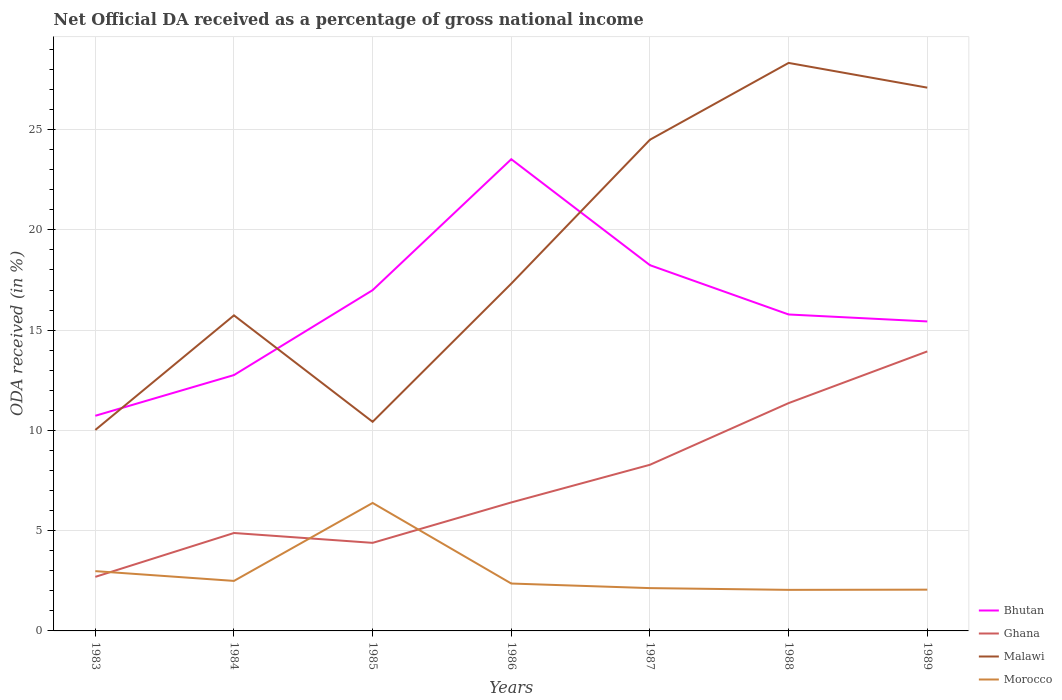Across all years, what is the maximum net official DA received in Ghana?
Give a very brief answer. 2.7. What is the total net official DA received in Malawi in the graph?
Provide a succinct answer. -7.18. What is the difference between the highest and the second highest net official DA received in Malawi?
Ensure brevity in your answer.  18.3. What is the difference between the highest and the lowest net official DA received in Malawi?
Keep it short and to the point. 3. Is the net official DA received in Ghana strictly greater than the net official DA received in Morocco over the years?
Make the answer very short. No. Are the values on the major ticks of Y-axis written in scientific E-notation?
Your response must be concise. No. Does the graph contain any zero values?
Ensure brevity in your answer.  No. What is the title of the graph?
Offer a very short reply. Net Official DA received as a percentage of gross national income. What is the label or title of the X-axis?
Your answer should be compact. Years. What is the label or title of the Y-axis?
Ensure brevity in your answer.  ODA received (in %). What is the ODA received (in %) of Bhutan in 1983?
Keep it short and to the point. 10.73. What is the ODA received (in %) in Ghana in 1983?
Provide a succinct answer. 2.7. What is the ODA received (in %) in Malawi in 1983?
Keep it short and to the point. 10.02. What is the ODA received (in %) of Morocco in 1983?
Ensure brevity in your answer.  2.98. What is the ODA received (in %) in Bhutan in 1984?
Provide a succinct answer. 12.76. What is the ODA received (in %) of Ghana in 1984?
Give a very brief answer. 4.88. What is the ODA received (in %) of Malawi in 1984?
Offer a terse response. 15.74. What is the ODA received (in %) in Morocco in 1984?
Provide a succinct answer. 2.49. What is the ODA received (in %) of Bhutan in 1985?
Offer a terse response. 16.99. What is the ODA received (in %) in Ghana in 1985?
Offer a terse response. 4.39. What is the ODA received (in %) of Malawi in 1985?
Make the answer very short. 10.43. What is the ODA received (in %) in Morocco in 1985?
Provide a short and direct response. 6.38. What is the ODA received (in %) of Bhutan in 1986?
Make the answer very short. 23.52. What is the ODA received (in %) in Ghana in 1986?
Provide a short and direct response. 6.41. What is the ODA received (in %) in Malawi in 1986?
Offer a terse response. 17.32. What is the ODA received (in %) in Morocco in 1986?
Keep it short and to the point. 2.36. What is the ODA received (in %) in Bhutan in 1987?
Your answer should be compact. 18.24. What is the ODA received (in %) of Ghana in 1987?
Your response must be concise. 8.29. What is the ODA received (in %) of Malawi in 1987?
Your response must be concise. 24.49. What is the ODA received (in %) of Morocco in 1987?
Offer a very short reply. 2.13. What is the ODA received (in %) of Bhutan in 1988?
Make the answer very short. 15.78. What is the ODA received (in %) of Ghana in 1988?
Offer a terse response. 11.36. What is the ODA received (in %) in Malawi in 1988?
Ensure brevity in your answer.  28.32. What is the ODA received (in %) of Morocco in 1988?
Offer a terse response. 2.05. What is the ODA received (in %) of Bhutan in 1989?
Your response must be concise. 15.43. What is the ODA received (in %) in Ghana in 1989?
Give a very brief answer. 13.94. What is the ODA received (in %) in Malawi in 1989?
Give a very brief answer. 27.09. What is the ODA received (in %) of Morocco in 1989?
Give a very brief answer. 2.06. Across all years, what is the maximum ODA received (in %) in Bhutan?
Offer a terse response. 23.52. Across all years, what is the maximum ODA received (in %) in Ghana?
Make the answer very short. 13.94. Across all years, what is the maximum ODA received (in %) in Malawi?
Provide a short and direct response. 28.32. Across all years, what is the maximum ODA received (in %) of Morocco?
Your response must be concise. 6.38. Across all years, what is the minimum ODA received (in %) of Bhutan?
Your response must be concise. 10.73. Across all years, what is the minimum ODA received (in %) of Ghana?
Ensure brevity in your answer.  2.7. Across all years, what is the minimum ODA received (in %) of Malawi?
Make the answer very short. 10.02. Across all years, what is the minimum ODA received (in %) of Morocco?
Provide a succinct answer. 2.05. What is the total ODA received (in %) of Bhutan in the graph?
Ensure brevity in your answer.  113.45. What is the total ODA received (in %) in Ghana in the graph?
Provide a succinct answer. 51.96. What is the total ODA received (in %) in Malawi in the graph?
Provide a short and direct response. 133.41. What is the total ODA received (in %) of Morocco in the graph?
Offer a terse response. 20.46. What is the difference between the ODA received (in %) in Bhutan in 1983 and that in 1984?
Make the answer very short. -2.03. What is the difference between the ODA received (in %) in Ghana in 1983 and that in 1984?
Keep it short and to the point. -2.19. What is the difference between the ODA received (in %) of Malawi in 1983 and that in 1984?
Your response must be concise. -5.71. What is the difference between the ODA received (in %) of Morocco in 1983 and that in 1984?
Offer a very short reply. 0.49. What is the difference between the ODA received (in %) of Bhutan in 1983 and that in 1985?
Keep it short and to the point. -6.26. What is the difference between the ODA received (in %) in Ghana in 1983 and that in 1985?
Your response must be concise. -1.7. What is the difference between the ODA received (in %) in Malawi in 1983 and that in 1985?
Keep it short and to the point. -0.41. What is the difference between the ODA received (in %) in Morocco in 1983 and that in 1985?
Make the answer very short. -3.4. What is the difference between the ODA received (in %) of Bhutan in 1983 and that in 1986?
Your response must be concise. -12.79. What is the difference between the ODA received (in %) in Ghana in 1983 and that in 1986?
Your answer should be compact. -3.71. What is the difference between the ODA received (in %) of Malawi in 1983 and that in 1986?
Keep it short and to the point. -7.3. What is the difference between the ODA received (in %) in Morocco in 1983 and that in 1986?
Your answer should be very brief. 0.62. What is the difference between the ODA received (in %) of Bhutan in 1983 and that in 1987?
Ensure brevity in your answer.  -7.51. What is the difference between the ODA received (in %) of Ghana in 1983 and that in 1987?
Provide a short and direct response. -5.59. What is the difference between the ODA received (in %) in Malawi in 1983 and that in 1987?
Your response must be concise. -14.47. What is the difference between the ODA received (in %) of Morocco in 1983 and that in 1987?
Your response must be concise. 0.85. What is the difference between the ODA received (in %) in Bhutan in 1983 and that in 1988?
Give a very brief answer. -5.05. What is the difference between the ODA received (in %) of Ghana in 1983 and that in 1988?
Your answer should be very brief. -8.66. What is the difference between the ODA received (in %) in Malawi in 1983 and that in 1988?
Provide a short and direct response. -18.3. What is the difference between the ODA received (in %) of Morocco in 1983 and that in 1988?
Offer a terse response. 0.93. What is the difference between the ODA received (in %) in Bhutan in 1983 and that in 1989?
Your response must be concise. -4.7. What is the difference between the ODA received (in %) of Ghana in 1983 and that in 1989?
Provide a succinct answer. -11.24. What is the difference between the ODA received (in %) in Malawi in 1983 and that in 1989?
Provide a short and direct response. -17.07. What is the difference between the ODA received (in %) of Morocco in 1983 and that in 1989?
Provide a succinct answer. 0.92. What is the difference between the ODA received (in %) of Bhutan in 1984 and that in 1985?
Provide a succinct answer. -4.24. What is the difference between the ODA received (in %) in Ghana in 1984 and that in 1985?
Keep it short and to the point. 0.49. What is the difference between the ODA received (in %) of Malawi in 1984 and that in 1985?
Offer a very short reply. 5.31. What is the difference between the ODA received (in %) of Morocco in 1984 and that in 1985?
Provide a short and direct response. -3.89. What is the difference between the ODA received (in %) in Bhutan in 1984 and that in 1986?
Your response must be concise. -10.76. What is the difference between the ODA received (in %) of Ghana in 1984 and that in 1986?
Make the answer very short. -1.52. What is the difference between the ODA received (in %) of Malawi in 1984 and that in 1986?
Offer a very short reply. -1.58. What is the difference between the ODA received (in %) in Morocco in 1984 and that in 1986?
Make the answer very short. 0.13. What is the difference between the ODA received (in %) in Bhutan in 1984 and that in 1987?
Provide a succinct answer. -5.48. What is the difference between the ODA received (in %) in Ghana in 1984 and that in 1987?
Offer a very short reply. -3.4. What is the difference between the ODA received (in %) in Malawi in 1984 and that in 1987?
Keep it short and to the point. -8.76. What is the difference between the ODA received (in %) in Morocco in 1984 and that in 1987?
Your answer should be compact. 0.36. What is the difference between the ODA received (in %) of Bhutan in 1984 and that in 1988?
Ensure brevity in your answer.  -3.02. What is the difference between the ODA received (in %) of Ghana in 1984 and that in 1988?
Keep it short and to the point. -6.48. What is the difference between the ODA received (in %) in Malawi in 1984 and that in 1988?
Give a very brief answer. -12.59. What is the difference between the ODA received (in %) in Morocco in 1984 and that in 1988?
Your answer should be compact. 0.45. What is the difference between the ODA received (in %) in Bhutan in 1984 and that in 1989?
Keep it short and to the point. -2.67. What is the difference between the ODA received (in %) in Ghana in 1984 and that in 1989?
Make the answer very short. -9.05. What is the difference between the ODA received (in %) of Malawi in 1984 and that in 1989?
Keep it short and to the point. -11.36. What is the difference between the ODA received (in %) of Morocco in 1984 and that in 1989?
Make the answer very short. 0.44. What is the difference between the ODA received (in %) in Bhutan in 1985 and that in 1986?
Provide a short and direct response. -6.53. What is the difference between the ODA received (in %) in Ghana in 1985 and that in 1986?
Ensure brevity in your answer.  -2.02. What is the difference between the ODA received (in %) of Malawi in 1985 and that in 1986?
Keep it short and to the point. -6.89. What is the difference between the ODA received (in %) in Morocco in 1985 and that in 1986?
Give a very brief answer. 4.02. What is the difference between the ODA received (in %) of Bhutan in 1985 and that in 1987?
Your answer should be very brief. -1.25. What is the difference between the ODA received (in %) in Ghana in 1985 and that in 1987?
Ensure brevity in your answer.  -3.89. What is the difference between the ODA received (in %) in Malawi in 1985 and that in 1987?
Provide a short and direct response. -14.07. What is the difference between the ODA received (in %) in Morocco in 1985 and that in 1987?
Offer a very short reply. 4.25. What is the difference between the ODA received (in %) of Bhutan in 1985 and that in 1988?
Offer a very short reply. 1.21. What is the difference between the ODA received (in %) of Ghana in 1985 and that in 1988?
Keep it short and to the point. -6.97. What is the difference between the ODA received (in %) of Malawi in 1985 and that in 1988?
Ensure brevity in your answer.  -17.9. What is the difference between the ODA received (in %) in Morocco in 1985 and that in 1988?
Offer a very short reply. 4.33. What is the difference between the ODA received (in %) of Bhutan in 1985 and that in 1989?
Your answer should be very brief. 1.56. What is the difference between the ODA received (in %) in Ghana in 1985 and that in 1989?
Your answer should be compact. -9.55. What is the difference between the ODA received (in %) of Malawi in 1985 and that in 1989?
Ensure brevity in your answer.  -16.66. What is the difference between the ODA received (in %) in Morocco in 1985 and that in 1989?
Give a very brief answer. 4.32. What is the difference between the ODA received (in %) of Bhutan in 1986 and that in 1987?
Your answer should be very brief. 5.28. What is the difference between the ODA received (in %) of Ghana in 1986 and that in 1987?
Provide a succinct answer. -1.88. What is the difference between the ODA received (in %) in Malawi in 1986 and that in 1987?
Ensure brevity in your answer.  -7.18. What is the difference between the ODA received (in %) in Morocco in 1986 and that in 1987?
Ensure brevity in your answer.  0.23. What is the difference between the ODA received (in %) in Bhutan in 1986 and that in 1988?
Make the answer very short. 7.74. What is the difference between the ODA received (in %) in Ghana in 1986 and that in 1988?
Offer a very short reply. -4.95. What is the difference between the ODA received (in %) in Malawi in 1986 and that in 1988?
Offer a very short reply. -11.01. What is the difference between the ODA received (in %) of Morocco in 1986 and that in 1988?
Keep it short and to the point. 0.32. What is the difference between the ODA received (in %) of Bhutan in 1986 and that in 1989?
Provide a succinct answer. 8.09. What is the difference between the ODA received (in %) in Ghana in 1986 and that in 1989?
Provide a short and direct response. -7.53. What is the difference between the ODA received (in %) of Malawi in 1986 and that in 1989?
Ensure brevity in your answer.  -9.77. What is the difference between the ODA received (in %) of Morocco in 1986 and that in 1989?
Your answer should be compact. 0.31. What is the difference between the ODA received (in %) of Bhutan in 1987 and that in 1988?
Offer a terse response. 2.46. What is the difference between the ODA received (in %) of Ghana in 1987 and that in 1988?
Give a very brief answer. -3.08. What is the difference between the ODA received (in %) in Malawi in 1987 and that in 1988?
Provide a succinct answer. -3.83. What is the difference between the ODA received (in %) of Morocco in 1987 and that in 1988?
Offer a terse response. 0.09. What is the difference between the ODA received (in %) of Bhutan in 1987 and that in 1989?
Your answer should be compact. 2.81. What is the difference between the ODA received (in %) of Ghana in 1987 and that in 1989?
Keep it short and to the point. -5.65. What is the difference between the ODA received (in %) of Malawi in 1987 and that in 1989?
Give a very brief answer. -2.6. What is the difference between the ODA received (in %) in Morocco in 1987 and that in 1989?
Ensure brevity in your answer.  0.08. What is the difference between the ODA received (in %) of Bhutan in 1988 and that in 1989?
Provide a short and direct response. 0.35. What is the difference between the ODA received (in %) of Ghana in 1988 and that in 1989?
Give a very brief answer. -2.58. What is the difference between the ODA received (in %) of Malawi in 1988 and that in 1989?
Provide a succinct answer. 1.23. What is the difference between the ODA received (in %) in Morocco in 1988 and that in 1989?
Give a very brief answer. -0.01. What is the difference between the ODA received (in %) in Bhutan in 1983 and the ODA received (in %) in Ghana in 1984?
Your answer should be compact. 5.85. What is the difference between the ODA received (in %) of Bhutan in 1983 and the ODA received (in %) of Malawi in 1984?
Your answer should be compact. -5.01. What is the difference between the ODA received (in %) in Bhutan in 1983 and the ODA received (in %) in Morocco in 1984?
Offer a terse response. 8.23. What is the difference between the ODA received (in %) of Ghana in 1983 and the ODA received (in %) of Malawi in 1984?
Make the answer very short. -13.04. What is the difference between the ODA received (in %) in Ghana in 1983 and the ODA received (in %) in Morocco in 1984?
Make the answer very short. 0.2. What is the difference between the ODA received (in %) in Malawi in 1983 and the ODA received (in %) in Morocco in 1984?
Provide a succinct answer. 7.53. What is the difference between the ODA received (in %) in Bhutan in 1983 and the ODA received (in %) in Ghana in 1985?
Offer a very short reply. 6.34. What is the difference between the ODA received (in %) of Bhutan in 1983 and the ODA received (in %) of Malawi in 1985?
Provide a short and direct response. 0.3. What is the difference between the ODA received (in %) of Bhutan in 1983 and the ODA received (in %) of Morocco in 1985?
Provide a short and direct response. 4.35. What is the difference between the ODA received (in %) in Ghana in 1983 and the ODA received (in %) in Malawi in 1985?
Ensure brevity in your answer.  -7.73. What is the difference between the ODA received (in %) of Ghana in 1983 and the ODA received (in %) of Morocco in 1985?
Provide a succinct answer. -3.69. What is the difference between the ODA received (in %) in Malawi in 1983 and the ODA received (in %) in Morocco in 1985?
Give a very brief answer. 3.64. What is the difference between the ODA received (in %) of Bhutan in 1983 and the ODA received (in %) of Ghana in 1986?
Make the answer very short. 4.32. What is the difference between the ODA received (in %) of Bhutan in 1983 and the ODA received (in %) of Malawi in 1986?
Keep it short and to the point. -6.59. What is the difference between the ODA received (in %) in Bhutan in 1983 and the ODA received (in %) in Morocco in 1986?
Provide a succinct answer. 8.37. What is the difference between the ODA received (in %) in Ghana in 1983 and the ODA received (in %) in Malawi in 1986?
Offer a very short reply. -14.62. What is the difference between the ODA received (in %) of Ghana in 1983 and the ODA received (in %) of Morocco in 1986?
Offer a terse response. 0.33. What is the difference between the ODA received (in %) of Malawi in 1983 and the ODA received (in %) of Morocco in 1986?
Your answer should be compact. 7.66. What is the difference between the ODA received (in %) in Bhutan in 1983 and the ODA received (in %) in Ghana in 1987?
Keep it short and to the point. 2.44. What is the difference between the ODA received (in %) in Bhutan in 1983 and the ODA received (in %) in Malawi in 1987?
Make the answer very short. -13.77. What is the difference between the ODA received (in %) of Bhutan in 1983 and the ODA received (in %) of Morocco in 1987?
Provide a short and direct response. 8.59. What is the difference between the ODA received (in %) of Ghana in 1983 and the ODA received (in %) of Malawi in 1987?
Keep it short and to the point. -21.8. What is the difference between the ODA received (in %) of Ghana in 1983 and the ODA received (in %) of Morocco in 1987?
Offer a very short reply. 0.56. What is the difference between the ODA received (in %) in Malawi in 1983 and the ODA received (in %) in Morocco in 1987?
Give a very brief answer. 7.89. What is the difference between the ODA received (in %) in Bhutan in 1983 and the ODA received (in %) in Ghana in 1988?
Your response must be concise. -0.63. What is the difference between the ODA received (in %) of Bhutan in 1983 and the ODA received (in %) of Malawi in 1988?
Offer a terse response. -17.6. What is the difference between the ODA received (in %) in Bhutan in 1983 and the ODA received (in %) in Morocco in 1988?
Your answer should be very brief. 8.68. What is the difference between the ODA received (in %) in Ghana in 1983 and the ODA received (in %) in Malawi in 1988?
Your answer should be compact. -25.63. What is the difference between the ODA received (in %) in Ghana in 1983 and the ODA received (in %) in Morocco in 1988?
Keep it short and to the point. 0.65. What is the difference between the ODA received (in %) in Malawi in 1983 and the ODA received (in %) in Morocco in 1988?
Provide a short and direct response. 7.98. What is the difference between the ODA received (in %) in Bhutan in 1983 and the ODA received (in %) in Ghana in 1989?
Provide a short and direct response. -3.21. What is the difference between the ODA received (in %) of Bhutan in 1983 and the ODA received (in %) of Malawi in 1989?
Provide a short and direct response. -16.36. What is the difference between the ODA received (in %) of Bhutan in 1983 and the ODA received (in %) of Morocco in 1989?
Provide a succinct answer. 8.67. What is the difference between the ODA received (in %) of Ghana in 1983 and the ODA received (in %) of Malawi in 1989?
Your answer should be compact. -24.4. What is the difference between the ODA received (in %) in Ghana in 1983 and the ODA received (in %) in Morocco in 1989?
Offer a very short reply. 0.64. What is the difference between the ODA received (in %) in Malawi in 1983 and the ODA received (in %) in Morocco in 1989?
Provide a succinct answer. 7.96. What is the difference between the ODA received (in %) in Bhutan in 1984 and the ODA received (in %) in Ghana in 1985?
Your answer should be compact. 8.37. What is the difference between the ODA received (in %) of Bhutan in 1984 and the ODA received (in %) of Malawi in 1985?
Your response must be concise. 2.33. What is the difference between the ODA received (in %) of Bhutan in 1984 and the ODA received (in %) of Morocco in 1985?
Offer a very short reply. 6.38. What is the difference between the ODA received (in %) in Ghana in 1984 and the ODA received (in %) in Malawi in 1985?
Provide a short and direct response. -5.54. What is the difference between the ODA received (in %) of Ghana in 1984 and the ODA received (in %) of Morocco in 1985?
Ensure brevity in your answer.  -1.5. What is the difference between the ODA received (in %) in Malawi in 1984 and the ODA received (in %) in Morocco in 1985?
Your answer should be compact. 9.35. What is the difference between the ODA received (in %) in Bhutan in 1984 and the ODA received (in %) in Ghana in 1986?
Provide a succinct answer. 6.35. What is the difference between the ODA received (in %) in Bhutan in 1984 and the ODA received (in %) in Malawi in 1986?
Your answer should be very brief. -4.56. What is the difference between the ODA received (in %) of Bhutan in 1984 and the ODA received (in %) of Morocco in 1986?
Keep it short and to the point. 10.39. What is the difference between the ODA received (in %) in Ghana in 1984 and the ODA received (in %) in Malawi in 1986?
Offer a very short reply. -12.44. What is the difference between the ODA received (in %) in Ghana in 1984 and the ODA received (in %) in Morocco in 1986?
Provide a succinct answer. 2.52. What is the difference between the ODA received (in %) of Malawi in 1984 and the ODA received (in %) of Morocco in 1986?
Your response must be concise. 13.37. What is the difference between the ODA received (in %) of Bhutan in 1984 and the ODA received (in %) of Ghana in 1987?
Make the answer very short. 4.47. What is the difference between the ODA received (in %) of Bhutan in 1984 and the ODA received (in %) of Malawi in 1987?
Your answer should be compact. -11.74. What is the difference between the ODA received (in %) in Bhutan in 1984 and the ODA received (in %) in Morocco in 1987?
Provide a succinct answer. 10.62. What is the difference between the ODA received (in %) of Ghana in 1984 and the ODA received (in %) of Malawi in 1987?
Offer a very short reply. -19.61. What is the difference between the ODA received (in %) of Ghana in 1984 and the ODA received (in %) of Morocco in 1987?
Ensure brevity in your answer.  2.75. What is the difference between the ODA received (in %) in Malawi in 1984 and the ODA received (in %) in Morocco in 1987?
Ensure brevity in your answer.  13.6. What is the difference between the ODA received (in %) of Bhutan in 1984 and the ODA received (in %) of Ghana in 1988?
Provide a succinct answer. 1.4. What is the difference between the ODA received (in %) in Bhutan in 1984 and the ODA received (in %) in Malawi in 1988?
Your answer should be very brief. -15.57. What is the difference between the ODA received (in %) of Bhutan in 1984 and the ODA received (in %) of Morocco in 1988?
Make the answer very short. 10.71. What is the difference between the ODA received (in %) in Ghana in 1984 and the ODA received (in %) in Malawi in 1988?
Keep it short and to the point. -23.44. What is the difference between the ODA received (in %) of Ghana in 1984 and the ODA received (in %) of Morocco in 1988?
Ensure brevity in your answer.  2.84. What is the difference between the ODA received (in %) in Malawi in 1984 and the ODA received (in %) in Morocco in 1988?
Your response must be concise. 13.69. What is the difference between the ODA received (in %) in Bhutan in 1984 and the ODA received (in %) in Ghana in 1989?
Offer a terse response. -1.18. What is the difference between the ODA received (in %) in Bhutan in 1984 and the ODA received (in %) in Malawi in 1989?
Offer a very short reply. -14.33. What is the difference between the ODA received (in %) in Bhutan in 1984 and the ODA received (in %) in Morocco in 1989?
Offer a terse response. 10.7. What is the difference between the ODA received (in %) of Ghana in 1984 and the ODA received (in %) of Malawi in 1989?
Ensure brevity in your answer.  -22.21. What is the difference between the ODA received (in %) in Ghana in 1984 and the ODA received (in %) in Morocco in 1989?
Provide a short and direct response. 2.83. What is the difference between the ODA received (in %) in Malawi in 1984 and the ODA received (in %) in Morocco in 1989?
Give a very brief answer. 13.68. What is the difference between the ODA received (in %) in Bhutan in 1985 and the ODA received (in %) in Ghana in 1986?
Provide a succinct answer. 10.59. What is the difference between the ODA received (in %) of Bhutan in 1985 and the ODA received (in %) of Malawi in 1986?
Give a very brief answer. -0.33. What is the difference between the ODA received (in %) of Bhutan in 1985 and the ODA received (in %) of Morocco in 1986?
Offer a terse response. 14.63. What is the difference between the ODA received (in %) of Ghana in 1985 and the ODA received (in %) of Malawi in 1986?
Your response must be concise. -12.93. What is the difference between the ODA received (in %) of Ghana in 1985 and the ODA received (in %) of Morocco in 1986?
Offer a very short reply. 2.03. What is the difference between the ODA received (in %) in Malawi in 1985 and the ODA received (in %) in Morocco in 1986?
Make the answer very short. 8.06. What is the difference between the ODA received (in %) of Bhutan in 1985 and the ODA received (in %) of Ghana in 1987?
Your answer should be compact. 8.71. What is the difference between the ODA received (in %) in Bhutan in 1985 and the ODA received (in %) in Malawi in 1987?
Ensure brevity in your answer.  -7.5. What is the difference between the ODA received (in %) in Bhutan in 1985 and the ODA received (in %) in Morocco in 1987?
Offer a terse response. 14.86. What is the difference between the ODA received (in %) of Ghana in 1985 and the ODA received (in %) of Malawi in 1987?
Your response must be concise. -20.1. What is the difference between the ODA received (in %) of Ghana in 1985 and the ODA received (in %) of Morocco in 1987?
Give a very brief answer. 2.26. What is the difference between the ODA received (in %) in Malawi in 1985 and the ODA received (in %) in Morocco in 1987?
Make the answer very short. 8.29. What is the difference between the ODA received (in %) of Bhutan in 1985 and the ODA received (in %) of Ghana in 1988?
Provide a short and direct response. 5.63. What is the difference between the ODA received (in %) of Bhutan in 1985 and the ODA received (in %) of Malawi in 1988?
Ensure brevity in your answer.  -11.33. What is the difference between the ODA received (in %) of Bhutan in 1985 and the ODA received (in %) of Morocco in 1988?
Your response must be concise. 14.95. What is the difference between the ODA received (in %) of Ghana in 1985 and the ODA received (in %) of Malawi in 1988?
Ensure brevity in your answer.  -23.93. What is the difference between the ODA received (in %) of Ghana in 1985 and the ODA received (in %) of Morocco in 1988?
Your answer should be compact. 2.34. What is the difference between the ODA received (in %) in Malawi in 1985 and the ODA received (in %) in Morocco in 1988?
Provide a short and direct response. 8.38. What is the difference between the ODA received (in %) of Bhutan in 1985 and the ODA received (in %) of Ghana in 1989?
Give a very brief answer. 3.06. What is the difference between the ODA received (in %) of Bhutan in 1985 and the ODA received (in %) of Malawi in 1989?
Provide a short and direct response. -10.1. What is the difference between the ODA received (in %) in Bhutan in 1985 and the ODA received (in %) in Morocco in 1989?
Provide a short and direct response. 14.94. What is the difference between the ODA received (in %) of Ghana in 1985 and the ODA received (in %) of Malawi in 1989?
Your answer should be compact. -22.7. What is the difference between the ODA received (in %) in Ghana in 1985 and the ODA received (in %) in Morocco in 1989?
Your response must be concise. 2.33. What is the difference between the ODA received (in %) of Malawi in 1985 and the ODA received (in %) of Morocco in 1989?
Your answer should be compact. 8.37. What is the difference between the ODA received (in %) in Bhutan in 1986 and the ODA received (in %) in Ghana in 1987?
Your answer should be compact. 15.24. What is the difference between the ODA received (in %) of Bhutan in 1986 and the ODA received (in %) of Malawi in 1987?
Your answer should be very brief. -0.97. What is the difference between the ODA received (in %) in Bhutan in 1986 and the ODA received (in %) in Morocco in 1987?
Provide a succinct answer. 21.39. What is the difference between the ODA received (in %) of Ghana in 1986 and the ODA received (in %) of Malawi in 1987?
Your answer should be very brief. -18.09. What is the difference between the ODA received (in %) in Ghana in 1986 and the ODA received (in %) in Morocco in 1987?
Ensure brevity in your answer.  4.27. What is the difference between the ODA received (in %) of Malawi in 1986 and the ODA received (in %) of Morocco in 1987?
Ensure brevity in your answer.  15.18. What is the difference between the ODA received (in %) in Bhutan in 1986 and the ODA received (in %) in Ghana in 1988?
Ensure brevity in your answer.  12.16. What is the difference between the ODA received (in %) of Bhutan in 1986 and the ODA received (in %) of Malawi in 1988?
Ensure brevity in your answer.  -4.8. What is the difference between the ODA received (in %) in Bhutan in 1986 and the ODA received (in %) in Morocco in 1988?
Your response must be concise. 21.48. What is the difference between the ODA received (in %) of Ghana in 1986 and the ODA received (in %) of Malawi in 1988?
Provide a succinct answer. -21.92. What is the difference between the ODA received (in %) in Ghana in 1986 and the ODA received (in %) in Morocco in 1988?
Make the answer very short. 4.36. What is the difference between the ODA received (in %) in Malawi in 1986 and the ODA received (in %) in Morocco in 1988?
Offer a very short reply. 15.27. What is the difference between the ODA received (in %) in Bhutan in 1986 and the ODA received (in %) in Ghana in 1989?
Your answer should be very brief. 9.59. What is the difference between the ODA received (in %) of Bhutan in 1986 and the ODA received (in %) of Malawi in 1989?
Offer a terse response. -3.57. What is the difference between the ODA received (in %) in Bhutan in 1986 and the ODA received (in %) in Morocco in 1989?
Give a very brief answer. 21.46. What is the difference between the ODA received (in %) of Ghana in 1986 and the ODA received (in %) of Malawi in 1989?
Your response must be concise. -20.68. What is the difference between the ODA received (in %) of Ghana in 1986 and the ODA received (in %) of Morocco in 1989?
Make the answer very short. 4.35. What is the difference between the ODA received (in %) of Malawi in 1986 and the ODA received (in %) of Morocco in 1989?
Make the answer very short. 15.26. What is the difference between the ODA received (in %) in Bhutan in 1987 and the ODA received (in %) in Ghana in 1988?
Keep it short and to the point. 6.88. What is the difference between the ODA received (in %) in Bhutan in 1987 and the ODA received (in %) in Malawi in 1988?
Your answer should be very brief. -10.09. What is the difference between the ODA received (in %) in Bhutan in 1987 and the ODA received (in %) in Morocco in 1988?
Keep it short and to the point. 16.19. What is the difference between the ODA received (in %) of Ghana in 1987 and the ODA received (in %) of Malawi in 1988?
Keep it short and to the point. -20.04. What is the difference between the ODA received (in %) in Ghana in 1987 and the ODA received (in %) in Morocco in 1988?
Keep it short and to the point. 6.24. What is the difference between the ODA received (in %) of Malawi in 1987 and the ODA received (in %) of Morocco in 1988?
Your response must be concise. 22.45. What is the difference between the ODA received (in %) of Bhutan in 1987 and the ODA received (in %) of Ghana in 1989?
Provide a succinct answer. 4.3. What is the difference between the ODA received (in %) in Bhutan in 1987 and the ODA received (in %) in Malawi in 1989?
Provide a succinct answer. -8.85. What is the difference between the ODA received (in %) in Bhutan in 1987 and the ODA received (in %) in Morocco in 1989?
Your answer should be very brief. 16.18. What is the difference between the ODA received (in %) of Ghana in 1987 and the ODA received (in %) of Malawi in 1989?
Make the answer very short. -18.81. What is the difference between the ODA received (in %) of Ghana in 1987 and the ODA received (in %) of Morocco in 1989?
Give a very brief answer. 6.23. What is the difference between the ODA received (in %) of Malawi in 1987 and the ODA received (in %) of Morocco in 1989?
Keep it short and to the point. 22.44. What is the difference between the ODA received (in %) in Bhutan in 1988 and the ODA received (in %) in Ghana in 1989?
Your answer should be compact. 1.84. What is the difference between the ODA received (in %) of Bhutan in 1988 and the ODA received (in %) of Malawi in 1989?
Your answer should be very brief. -11.31. What is the difference between the ODA received (in %) of Bhutan in 1988 and the ODA received (in %) of Morocco in 1989?
Your answer should be very brief. 13.72. What is the difference between the ODA received (in %) of Ghana in 1988 and the ODA received (in %) of Malawi in 1989?
Your response must be concise. -15.73. What is the difference between the ODA received (in %) in Ghana in 1988 and the ODA received (in %) in Morocco in 1989?
Your response must be concise. 9.3. What is the difference between the ODA received (in %) in Malawi in 1988 and the ODA received (in %) in Morocco in 1989?
Provide a succinct answer. 26.27. What is the average ODA received (in %) in Bhutan per year?
Ensure brevity in your answer.  16.21. What is the average ODA received (in %) of Ghana per year?
Ensure brevity in your answer.  7.42. What is the average ODA received (in %) in Malawi per year?
Offer a terse response. 19.06. What is the average ODA received (in %) of Morocco per year?
Provide a succinct answer. 2.92. In the year 1983, what is the difference between the ODA received (in %) of Bhutan and ODA received (in %) of Ghana?
Your answer should be compact. 8.03. In the year 1983, what is the difference between the ODA received (in %) in Bhutan and ODA received (in %) in Malawi?
Your answer should be very brief. 0.71. In the year 1983, what is the difference between the ODA received (in %) in Bhutan and ODA received (in %) in Morocco?
Offer a very short reply. 7.75. In the year 1983, what is the difference between the ODA received (in %) in Ghana and ODA received (in %) in Malawi?
Your answer should be compact. -7.33. In the year 1983, what is the difference between the ODA received (in %) of Ghana and ODA received (in %) of Morocco?
Provide a short and direct response. -0.29. In the year 1983, what is the difference between the ODA received (in %) of Malawi and ODA received (in %) of Morocco?
Provide a succinct answer. 7.04. In the year 1984, what is the difference between the ODA received (in %) in Bhutan and ODA received (in %) in Ghana?
Provide a short and direct response. 7.88. In the year 1984, what is the difference between the ODA received (in %) in Bhutan and ODA received (in %) in Malawi?
Your answer should be very brief. -2.98. In the year 1984, what is the difference between the ODA received (in %) of Bhutan and ODA received (in %) of Morocco?
Make the answer very short. 10.26. In the year 1984, what is the difference between the ODA received (in %) of Ghana and ODA received (in %) of Malawi?
Provide a succinct answer. -10.85. In the year 1984, what is the difference between the ODA received (in %) in Ghana and ODA received (in %) in Morocco?
Keep it short and to the point. 2.39. In the year 1984, what is the difference between the ODA received (in %) of Malawi and ODA received (in %) of Morocco?
Your response must be concise. 13.24. In the year 1985, what is the difference between the ODA received (in %) in Bhutan and ODA received (in %) in Ghana?
Your response must be concise. 12.6. In the year 1985, what is the difference between the ODA received (in %) of Bhutan and ODA received (in %) of Malawi?
Provide a succinct answer. 6.57. In the year 1985, what is the difference between the ODA received (in %) in Bhutan and ODA received (in %) in Morocco?
Your response must be concise. 10.61. In the year 1985, what is the difference between the ODA received (in %) in Ghana and ODA received (in %) in Malawi?
Provide a succinct answer. -6.04. In the year 1985, what is the difference between the ODA received (in %) of Ghana and ODA received (in %) of Morocco?
Give a very brief answer. -1.99. In the year 1985, what is the difference between the ODA received (in %) of Malawi and ODA received (in %) of Morocco?
Offer a very short reply. 4.05. In the year 1986, what is the difference between the ODA received (in %) of Bhutan and ODA received (in %) of Ghana?
Your answer should be very brief. 17.12. In the year 1986, what is the difference between the ODA received (in %) of Bhutan and ODA received (in %) of Malawi?
Keep it short and to the point. 6.2. In the year 1986, what is the difference between the ODA received (in %) of Bhutan and ODA received (in %) of Morocco?
Keep it short and to the point. 21.16. In the year 1986, what is the difference between the ODA received (in %) in Ghana and ODA received (in %) in Malawi?
Give a very brief answer. -10.91. In the year 1986, what is the difference between the ODA received (in %) in Ghana and ODA received (in %) in Morocco?
Keep it short and to the point. 4.04. In the year 1986, what is the difference between the ODA received (in %) in Malawi and ODA received (in %) in Morocco?
Give a very brief answer. 14.96. In the year 1987, what is the difference between the ODA received (in %) of Bhutan and ODA received (in %) of Ghana?
Make the answer very short. 9.95. In the year 1987, what is the difference between the ODA received (in %) of Bhutan and ODA received (in %) of Malawi?
Your answer should be very brief. -6.26. In the year 1987, what is the difference between the ODA received (in %) in Bhutan and ODA received (in %) in Morocco?
Your response must be concise. 16.1. In the year 1987, what is the difference between the ODA received (in %) of Ghana and ODA received (in %) of Malawi?
Your answer should be very brief. -16.21. In the year 1987, what is the difference between the ODA received (in %) of Ghana and ODA received (in %) of Morocco?
Provide a short and direct response. 6.15. In the year 1987, what is the difference between the ODA received (in %) in Malawi and ODA received (in %) in Morocco?
Offer a very short reply. 22.36. In the year 1988, what is the difference between the ODA received (in %) of Bhutan and ODA received (in %) of Ghana?
Provide a succinct answer. 4.42. In the year 1988, what is the difference between the ODA received (in %) of Bhutan and ODA received (in %) of Malawi?
Provide a succinct answer. -12.54. In the year 1988, what is the difference between the ODA received (in %) in Bhutan and ODA received (in %) in Morocco?
Keep it short and to the point. 13.73. In the year 1988, what is the difference between the ODA received (in %) in Ghana and ODA received (in %) in Malawi?
Your answer should be very brief. -16.96. In the year 1988, what is the difference between the ODA received (in %) of Ghana and ODA received (in %) of Morocco?
Your answer should be compact. 9.31. In the year 1988, what is the difference between the ODA received (in %) of Malawi and ODA received (in %) of Morocco?
Your response must be concise. 26.28. In the year 1989, what is the difference between the ODA received (in %) of Bhutan and ODA received (in %) of Ghana?
Your response must be concise. 1.5. In the year 1989, what is the difference between the ODA received (in %) in Bhutan and ODA received (in %) in Malawi?
Your answer should be very brief. -11.66. In the year 1989, what is the difference between the ODA received (in %) in Bhutan and ODA received (in %) in Morocco?
Give a very brief answer. 13.38. In the year 1989, what is the difference between the ODA received (in %) in Ghana and ODA received (in %) in Malawi?
Your answer should be very brief. -13.15. In the year 1989, what is the difference between the ODA received (in %) of Ghana and ODA received (in %) of Morocco?
Provide a short and direct response. 11.88. In the year 1989, what is the difference between the ODA received (in %) of Malawi and ODA received (in %) of Morocco?
Give a very brief answer. 25.03. What is the ratio of the ODA received (in %) of Bhutan in 1983 to that in 1984?
Offer a very short reply. 0.84. What is the ratio of the ODA received (in %) of Ghana in 1983 to that in 1984?
Your response must be concise. 0.55. What is the ratio of the ODA received (in %) in Malawi in 1983 to that in 1984?
Give a very brief answer. 0.64. What is the ratio of the ODA received (in %) of Morocco in 1983 to that in 1984?
Your answer should be very brief. 1.2. What is the ratio of the ODA received (in %) of Bhutan in 1983 to that in 1985?
Provide a succinct answer. 0.63. What is the ratio of the ODA received (in %) in Ghana in 1983 to that in 1985?
Provide a short and direct response. 0.61. What is the ratio of the ODA received (in %) in Malawi in 1983 to that in 1985?
Your answer should be very brief. 0.96. What is the ratio of the ODA received (in %) in Morocco in 1983 to that in 1985?
Offer a very short reply. 0.47. What is the ratio of the ODA received (in %) in Bhutan in 1983 to that in 1986?
Keep it short and to the point. 0.46. What is the ratio of the ODA received (in %) of Ghana in 1983 to that in 1986?
Make the answer very short. 0.42. What is the ratio of the ODA received (in %) of Malawi in 1983 to that in 1986?
Keep it short and to the point. 0.58. What is the ratio of the ODA received (in %) in Morocco in 1983 to that in 1986?
Make the answer very short. 1.26. What is the ratio of the ODA received (in %) in Bhutan in 1983 to that in 1987?
Your response must be concise. 0.59. What is the ratio of the ODA received (in %) of Ghana in 1983 to that in 1987?
Ensure brevity in your answer.  0.33. What is the ratio of the ODA received (in %) in Malawi in 1983 to that in 1987?
Provide a succinct answer. 0.41. What is the ratio of the ODA received (in %) in Morocco in 1983 to that in 1987?
Keep it short and to the point. 1.4. What is the ratio of the ODA received (in %) in Bhutan in 1983 to that in 1988?
Make the answer very short. 0.68. What is the ratio of the ODA received (in %) of Ghana in 1983 to that in 1988?
Provide a short and direct response. 0.24. What is the ratio of the ODA received (in %) in Malawi in 1983 to that in 1988?
Make the answer very short. 0.35. What is the ratio of the ODA received (in %) in Morocco in 1983 to that in 1988?
Your answer should be very brief. 1.46. What is the ratio of the ODA received (in %) of Bhutan in 1983 to that in 1989?
Offer a very short reply. 0.7. What is the ratio of the ODA received (in %) in Ghana in 1983 to that in 1989?
Ensure brevity in your answer.  0.19. What is the ratio of the ODA received (in %) in Malawi in 1983 to that in 1989?
Offer a very short reply. 0.37. What is the ratio of the ODA received (in %) in Morocco in 1983 to that in 1989?
Provide a short and direct response. 1.45. What is the ratio of the ODA received (in %) in Bhutan in 1984 to that in 1985?
Make the answer very short. 0.75. What is the ratio of the ODA received (in %) in Ghana in 1984 to that in 1985?
Make the answer very short. 1.11. What is the ratio of the ODA received (in %) in Malawi in 1984 to that in 1985?
Your response must be concise. 1.51. What is the ratio of the ODA received (in %) in Morocco in 1984 to that in 1985?
Give a very brief answer. 0.39. What is the ratio of the ODA received (in %) in Bhutan in 1984 to that in 1986?
Offer a terse response. 0.54. What is the ratio of the ODA received (in %) in Ghana in 1984 to that in 1986?
Offer a very short reply. 0.76. What is the ratio of the ODA received (in %) in Malawi in 1984 to that in 1986?
Your answer should be very brief. 0.91. What is the ratio of the ODA received (in %) of Morocco in 1984 to that in 1986?
Provide a succinct answer. 1.06. What is the ratio of the ODA received (in %) of Bhutan in 1984 to that in 1987?
Give a very brief answer. 0.7. What is the ratio of the ODA received (in %) in Ghana in 1984 to that in 1987?
Your answer should be very brief. 0.59. What is the ratio of the ODA received (in %) of Malawi in 1984 to that in 1987?
Your response must be concise. 0.64. What is the ratio of the ODA received (in %) of Morocco in 1984 to that in 1987?
Provide a short and direct response. 1.17. What is the ratio of the ODA received (in %) in Bhutan in 1984 to that in 1988?
Your answer should be compact. 0.81. What is the ratio of the ODA received (in %) in Ghana in 1984 to that in 1988?
Your response must be concise. 0.43. What is the ratio of the ODA received (in %) of Malawi in 1984 to that in 1988?
Offer a terse response. 0.56. What is the ratio of the ODA received (in %) in Morocco in 1984 to that in 1988?
Offer a terse response. 1.22. What is the ratio of the ODA received (in %) of Bhutan in 1984 to that in 1989?
Ensure brevity in your answer.  0.83. What is the ratio of the ODA received (in %) of Ghana in 1984 to that in 1989?
Keep it short and to the point. 0.35. What is the ratio of the ODA received (in %) in Malawi in 1984 to that in 1989?
Your answer should be compact. 0.58. What is the ratio of the ODA received (in %) in Morocco in 1984 to that in 1989?
Your answer should be compact. 1.21. What is the ratio of the ODA received (in %) in Bhutan in 1985 to that in 1986?
Ensure brevity in your answer.  0.72. What is the ratio of the ODA received (in %) of Ghana in 1985 to that in 1986?
Your response must be concise. 0.69. What is the ratio of the ODA received (in %) in Malawi in 1985 to that in 1986?
Your response must be concise. 0.6. What is the ratio of the ODA received (in %) in Morocco in 1985 to that in 1986?
Provide a succinct answer. 2.7. What is the ratio of the ODA received (in %) of Bhutan in 1985 to that in 1987?
Your response must be concise. 0.93. What is the ratio of the ODA received (in %) in Ghana in 1985 to that in 1987?
Your answer should be very brief. 0.53. What is the ratio of the ODA received (in %) of Malawi in 1985 to that in 1987?
Ensure brevity in your answer.  0.43. What is the ratio of the ODA received (in %) of Morocco in 1985 to that in 1987?
Your answer should be compact. 2.99. What is the ratio of the ODA received (in %) of Bhutan in 1985 to that in 1988?
Offer a terse response. 1.08. What is the ratio of the ODA received (in %) of Ghana in 1985 to that in 1988?
Provide a short and direct response. 0.39. What is the ratio of the ODA received (in %) in Malawi in 1985 to that in 1988?
Provide a succinct answer. 0.37. What is the ratio of the ODA received (in %) of Morocco in 1985 to that in 1988?
Ensure brevity in your answer.  3.12. What is the ratio of the ODA received (in %) of Bhutan in 1985 to that in 1989?
Your answer should be compact. 1.1. What is the ratio of the ODA received (in %) of Ghana in 1985 to that in 1989?
Your answer should be very brief. 0.32. What is the ratio of the ODA received (in %) in Malawi in 1985 to that in 1989?
Make the answer very short. 0.38. What is the ratio of the ODA received (in %) in Morocco in 1985 to that in 1989?
Your answer should be compact. 3.1. What is the ratio of the ODA received (in %) of Bhutan in 1986 to that in 1987?
Your answer should be very brief. 1.29. What is the ratio of the ODA received (in %) of Ghana in 1986 to that in 1987?
Provide a short and direct response. 0.77. What is the ratio of the ODA received (in %) of Malawi in 1986 to that in 1987?
Your answer should be compact. 0.71. What is the ratio of the ODA received (in %) of Morocco in 1986 to that in 1987?
Ensure brevity in your answer.  1.11. What is the ratio of the ODA received (in %) of Bhutan in 1986 to that in 1988?
Offer a terse response. 1.49. What is the ratio of the ODA received (in %) in Ghana in 1986 to that in 1988?
Your answer should be compact. 0.56. What is the ratio of the ODA received (in %) of Malawi in 1986 to that in 1988?
Offer a very short reply. 0.61. What is the ratio of the ODA received (in %) in Morocco in 1986 to that in 1988?
Provide a succinct answer. 1.15. What is the ratio of the ODA received (in %) in Bhutan in 1986 to that in 1989?
Give a very brief answer. 1.52. What is the ratio of the ODA received (in %) of Ghana in 1986 to that in 1989?
Ensure brevity in your answer.  0.46. What is the ratio of the ODA received (in %) in Malawi in 1986 to that in 1989?
Offer a very short reply. 0.64. What is the ratio of the ODA received (in %) of Morocco in 1986 to that in 1989?
Make the answer very short. 1.15. What is the ratio of the ODA received (in %) in Bhutan in 1987 to that in 1988?
Your response must be concise. 1.16. What is the ratio of the ODA received (in %) in Ghana in 1987 to that in 1988?
Your answer should be compact. 0.73. What is the ratio of the ODA received (in %) of Malawi in 1987 to that in 1988?
Your response must be concise. 0.86. What is the ratio of the ODA received (in %) in Morocco in 1987 to that in 1988?
Provide a succinct answer. 1.04. What is the ratio of the ODA received (in %) in Bhutan in 1987 to that in 1989?
Make the answer very short. 1.18. What is the ratio of the ODA received (in %) of Ghana in 1987 to that in 1989?
Make the answer very short. 0.59. What is the ratio of the ODA received (in %) in Malawi in 1987 to that in 1989?
Provide a short and direct response. 0.9. What is the ratio of the ODA received (in %) in Morocco in 1987 to that in 1989?
Your answer should be compact. 1.04. What is the ratio of the ODA received (in %) of Bhutan in 1988 to that in 1989?
Your response must be concise. 1.02. What is the ratio of the ODA received (in %) of Ghana in 1988 to that in 1989?
Your answer should be very brief. 0.82. What is the ratio of the ODA received (in %) of Malawi in 1988 to that in 1989?
Ensure brevity in your answer.  1.05. What is the ratio of the ODA received (in %) in Morocco in 1988 to that in 1989?
Provide a succinct answer. 0.99. What is the difference between the highest and the second highest ODA received (in %) in Bhutan?
Your answer should be very brief. 5.28. What is the difference between the highest and the second highest ODA received (in %) of Ghana?
Keep it short and to the point. 2.58. What is the difference between the highest and the second highest ODA received (in %) of Malawi?
Provide a succinct answer. 1.23. What is the difference between the highest and the second highest ODA received (in %) in Morocco?
Provide a short and direct response. 3.4. What is the difference between the highest and the lowest ODA received (in %) in Bhutan?
Ensure brevity in your answer.  12.79. What is the difference between the highest and the lowest ODA received (in %) in Ghana?
Provide a short and direct response. 11.24. What is the difference between the highest and the lowest ODA received (in %) of Malawi?
Provide a succinct answer. 18.3. What is the difference between the highest and the lowest ODA received (in %) in Morocco?
Provide a short and direct response. 4.33. 